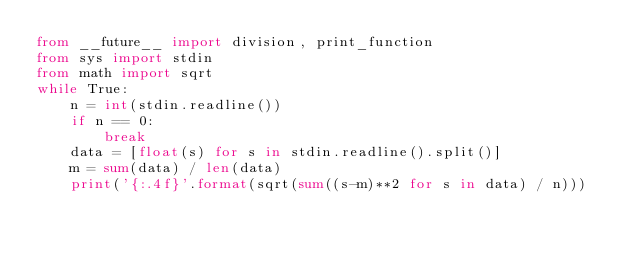<code> <loc_0><loc_0><loc_500><loc_500><_Python_>from __future__ import division, print_function
from sys import stdin
from math import sqrt
while True:
    n = int(stdin.readline())
    if n == 0:
        break
    data = [float(s) for s in stdin.readline().split()]
    m = sum(data) / len(data)
    print('{:.4f}'.format(sqrt(sum((s-m)**2 for s in data) / n)))</code> 